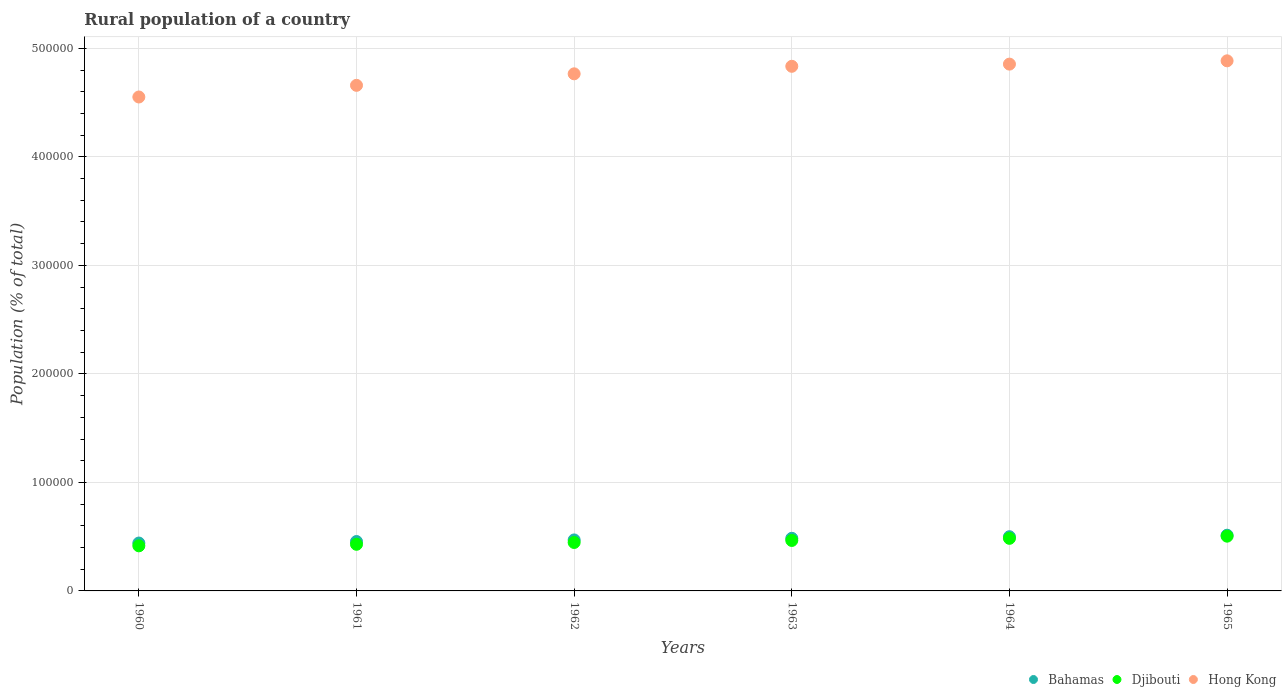Is the number of dotlines equal to the number of legend labels?
Make the answer very short. Yes. What is the rural population in Djibouti in 1962?
Offer a terse response. 4.46e+04. Across all years, what is the maximum rural population in Bahamas?
Your answer should be very brief. 5.13e+04. Across all years, what is the minimum rural population in Djibouti?
Ensure brevity in your answer.  4.15e+04. In which year was the rural population in Hong Kong maximum?
Offer a terse response. 1965. What is the total rural population in Bahamas in the graph?
Your answer should be very brief. 2.86e+05. What is the difference between the rural population in Bahamas in 1962 and that in 1963?
Offer a very short reply. -1491. What is the difference between the rural population in Bahamas in 1960 and the rural population in Djibouti in 1963?
Provide a short and direct response. -2374. What is the average rural population in Bahamas per year?
Offer a very short reply. 4.77e+04. In the year 1963, what is the difference between the rural population in Hong Kong and rural population in Djibouti?
Offer a very short reply. 4.37e+05. What is the ratio of the rural population in Bahamas in 1964 to that in 1965?
Offer a terse response. 0.97. Is the rural population in Hong Kong in 1960 less than that in 1962?
Offer a terse response. Yes. What is the difference between the highest and the second highest rural population in Hong Kong?
Give a very brief answer. 3031. What is the difference between the highest and the lowest rural population in Bahamas?
Make the answer very short. 7212. In how many years, is the rural population in Bahamas greater than the average rural population in Bahamas taken over all years?
Keep it short and to the point. 3. Does the rural population in Hong Kong monotonically increase over the years?
Your answer should be very brief. Yes. Is the rural population in Djibouti strictly less than the rural population in Bahamas over the years?
Keep it short and to the point. Yes. What is the difference between two consecutive major ticks on the Y-axis?
Your answer should be very brief. 1.00e+05. Does the graph contain grids?
Offer a very short reply. Yes. Where does the legend appear in the graph?
Your answer should be very brief. Bottom right. What is the title of the graph?
Keep it short and to the point. Rural population of a country. What is the label or title of the Y-axis?
Ensure brevity in your answer.  Population (% of total). What is the Population (% of total) in Bahamas in 1960?
Give a very brief answer. 4.41e+04. What is the Population (% of total) in Djibouti in 1960?
Your answer should be compact. 4.15e+04. What is the Population (% of total) in Hong Kong in 1960?
Offer a terse response. 4.55e+05. What is the Population (% of total) of Bahamas in 1961?
Keep it short and to the point. 4.55e+04. What is the Population (% of total) in Djibouti in 1961?
Provide a short and direct response. 4.30e+04. What is the Population (% of total) of Hong Kong in 1961?
Your answer should be very brief. 4.66e+05. What is the Population (% of total) of Bahamas in 1962?
Ensure brevity in your answer.  4.70e+04. What is the Population (% of total) of Djibouti in 1962?
Your answer should be compact. 4.46e+04. What is the Population (% of total) in Hong Kong in 1962?
Your response must be concise. 4.77e+05. What is the Population (% of total) of Bahamas in 1963?
Make the answer very short. 4.85e+04. What is the Population (% of total) of Djibouti in 1963?
Keep it short and to the point. 4.65e+04. What is the Population (% of total) in Hong Kong in 1963?
Your answer should be very brief. 4.83e+05. What is the Population (% of total) in Bahamas in 1964?
Offer a terse response. 4.99e+04. What is the Population (% of total) of Djibouti in 1964?
Provide a short and direct response. 4.85e+04. What is the Population (% of total) in Hong Kong in 1964?
Keep it short and to the point. 4.85e+05. What is the Population (% of total) in Bahamas in 1965?
Provide a succinct answer. 5.13e+04. What is the Population (% of total) in Djibouti in 1965?
Ensure brevity in your answer.  5.05e+04. What is the Population (% of total) of Hong Kong in 1965?
Your answer should be very brief. 4.89e+05. Across all years, what is the maximum Population (% of total) in Bahamas?
Ensure brevity in your answer.  5.13e+04. Across all years, what is the maximum Population (% of total) in Djibouti?
Your answer should be compact. 5.05e+04. Across all years, what is the maximum Population (% of total) in Hong Kong?
Offer a terse response. 4.89e+05. Across all years, what is the minimum Population (% of total) in Bahamas?
Your answer should be compact. 4.41e+04. Across all years, what is the minimum Population (% of total) of Djibouti?
Keep it short and to the point. 4.15e+04. Across all years, what is the minimum Population (% of total) of Hong Kong?
Your answer should be very brief. 4.55e+05. What is the total Population (% of total) in Bahamas in the graph?
Your answer should be compact. 2.86e+05. What is the total Population (% of total) of Djibouti in the graph?
Provide a succinct answer. 2.75e+05. What is the total Population (% of total) in Hong Kong in the graph?
Ensure brevity in your answer.  2.86e+06. What is the difference between the Population (% of total) of Bahamas in 1960 and that in 1961?
Ensure brevity in your answer.  -1395. What is the difference between the Population (% of total) in Djibouti in 1960 and that in 1961?
Offer a terse response. -1422. What is the difference between the Population (% of total) of Hong Kong in 1960 and that in 1961?
Ensure brevity in your answer.  -1.07e+04. What is the difference between the Population (% of total) in Bahamas in 1960 and that in 1962?
Your answer should be compact. -2863. What is the difference between the Population (% of total) of Djibouti in 1960 and that in 1962?
Give a very brief answer. -3087. What is the difference between the Population (% of total) in Hong Kong in 1960 and that in 1962?
Your response must be concise. -2.14e+04. What is the difference between the Population (% of total) of Bahamas in 1960 and that in 1963?
Keep it short and to the point. -4354. What is the difference between the Population (% of total) in Djibouti in 1960 and that in 1963?
Offer a very short reply. -4954. What is the difference between the Population (% of total) of Hong Kong in 1960 and that in 1963?
Give a very brief answer. -2.83e+04. What is the difference between the Population (% of total) of Bahamas in 1960 and that in 1964?
Ensure brevity in your answer.  -5821. What is the difference between the Population (% of total) of Djibouti in 1960 and that in 1964?
Your answer should be very brief. -6918. What is the difference between the Population (% of total) in Hong Kong in 1960 and that in 1964?
Your answer should be very brief. -3.03e+04. What is the difference between the Population (% of total) in Bahamas in 1960 and that in 1965?
Ensure brevity in your answer.  -7212. What is the difference between the Population (% of total) of Djibouti in 1960 and that in 1965?
Provide a succinct answer. -8912. What is the difference between the Population (% of total) of Hong Kong in 1960 and that in 1965?
Provide a succinct answer. -3.33e+04. What is the difference between the Population (% of total) of Bahamas in 1961 and that in 1962?
Your answer should be very brief. -1468. What is the difference between the Population (% of total) of Djibouti in 1961 and that in 1962?
Offer a terse response. -1665. What is the difference between the Population (% of total) in Hong Kong in 1961 and that in 1962?
Offer a very short reply. -1.06e+04. What is the difference between the Population (% of total) of Bahamas in 1961 and that in 1963?
Offer a terse response. -2959. What is the difference between the Population (% of total) in Djibouti in 1961 and that in 1963?
Give a very brief answer. -3532. What is the difference between the Population (% of total) in Hong Kong in 1961 and that in 1963?
Keep it short and to the point. -1.75e+04. What is the difference between the Population (% of total) of Bahamas in 1961 and that in 1964?
Ensure brevity in your answer.  -4426. What is the difference between the Population (% of total) of Djibouti in 1961 and that in 1964?
Offer a very short reply. -5496. What is the difference between the Population (% of total) in Hong Kong in 1961 and that in 1964?
Keep it short and to the point. -1.96e+04. What is the difference between the Population (% of total) in Bahamas in 1961 and that in 1965?
Give a very brief answer. -5817. What is the difference between the Population (% of total) of Djibouti in 1961 and that in 1965?
Keep it short and to the point. -7490. What is the difference between the Population (% of total) in Hong Kong in 1961 and that in 1965?
Ensure brevity in your answer.  -2.26e+04. What is the difference between the Population (% of total) of Bahamas in 1962 and that in 1963?
Give a very brief answer. -1491. What is the difference between the Population (% of total) of Djibouti in 1962 and that in 1963?
Provide a succinct answer. -1867. What is the difference between the Population (% of total) of Hong Kong in 1962 and that in 1963?
Offer a very short reply. -6932. What is the difference between the Population (% of total) in Bahamas in 1962 and that in 1964?
Provide a short and direct response. -2958. What is the difference between the Population (% of total) of Djibouti in 1962 and that in 1964?
Make the answer very short. -3831. What is the difference between the Population (% of total) of Hong Kong in 1962 and that in 1964?
Keep it short and to the point. -8948. What is the difference between the Population (% of total) in Bahamas in 1962 and that in 1965?
Provide a succinct answer. -4349. What is the difference between the Population (% of total) in Djibouti in 1962 and that in 1965?
Your response must be concise. -5825. What is the difference between the Population (% of total) of Hong Kong in 1962 and that in 1965?
Provide a succinct answer. -1.20e+04. What is the difference between the Population (% of total) of Bahamas in 1963 and that in 1964?
Ensure brevity in your answer.  -1467. What is the difference between the Population (% of total) in Djibouti in 1963 and that in 1964?
Give a very brief answer. -1964. What is the difference between the Population (% of total) in Hong Kong in 1963 and that in 1964?
Provide a short and direct response. -2016. What is the difference between the Population (% of total) of Bahamas in 1963 and that in 1965?
Make the answer very short. -2858. What is the difference between the Population (% of total) in Djibouti in 1963 and that in 1965?
Provide a short and direct response. -3958. What is the difference between the Population (% of total) of Hong Kong in 1963 and that in 1965?
Offer a terse response. -5047. What is the difference between the Population (% of total) in Bahamas in 1964 and that in 1965?
Give a very brief answer. -1391. What is the difference between the Population (% of total) of Djibouti in 1964 and that in 1965?
Your response must be concise. -1994. What is the difference between the Population (% of total) in Hong Kong in 1964 and that in 1965?
Offer a terse response. -3031. What is the difference between the Population (% of total) in Bahamas in 1960 and the Population (% of total) in Djibouti in 1961?
Provide a short and direct response. 1158. What is the difference between the Population (% of total) in Bahamas in 1960 and the Population (% of total) in Hong Kong in 1961?
Your response must be concise. -4.22e+05. What is the difference between the Population (% of total) in Djibouti in 1960 and the Population (% of total) in Hong Kong in 1961?
Ensure brevity in your answer.  -4.24e+05. What is the difference between the Population (% of total) of Bahamas in 1960 and the Population (% of total) of Djibouti in 1962?
Offer a very short reply. -507. What is the difference between the Population (% of total) in Bahamas in 1960 and the Population (% of total) in Hong Kong in 1962?
Offer a very short reply. -4.32e+05. What is the difference between the Population (% of total) in Djibouti in 1960 and the Population (% of total) in Hong Kong in 1962?
Ensure brevity in your answer.  -4.35e+05. What is the difference between the Population (% of total) in Bahamas in 1960 and the Population (% of total) in Djibouti in 1963?
Your answer should be very brief. -2374. What is the difference between the Population (% of total) of Bahamas in 1960 and the Population (% of total) of Hong Kong in 1963?
Provide a succinct answer. -4.39e+05. What is the difference between the Population (% of total) in Djibouti in 1960 and the Population (% of total) in Hong Kong in 1963?
Ensure brevity in your answer.  -4.42e+05. What is the difference between the Population (% of total) in Bahamas in 1960 and the Population (% of total) in Djibouti in 1964?
Give a very brief answer. -4338. What is the difference between the Population (% of total) in Bahamas in 1960 and the Population (% of total) in Hong Kong in 1964?
Offer a very short reply. -4.41e+05. What is the difference between the Population (% of total) of Djibouti in 1960 and the Population (% of total) of Hong Kong in 1964?
Offer a terse response. -4.44e+05. What is the difference between the Population (% of total) of Bahamas in 1960 and the Population (% of total) of Djibouti in 1965?
Offer a very short reply. -6332. What is the difference between the Population (% of total) in Bahamas in 1960 and the Population (% of total) in Hong Kong in 1965?
Ensure brevity in your answer.  -4.44e+05. What is the difference between the Population (% of total) in Djibouti in 1960 and the Population (% of total) in Hong Kong in 1965?
Give a very brief answer. -4.47e+05. What is the difference between the Population (% of total) in Bahamas in 1961 and the Population (% of total) in Djibouti in 1962?
Offer a very short reply. 888. What is the difference between the Population (% of total) of Bahamas in 1961 and the Population (% of total) of Hong Kong in 1962?
Provide a succinct answer. -4.31e+05. What is the difference between the Population (% of total) in Djibouti in 1961 and the Population (% of total) in Hong Kong in 1962?
Ensure brevity in your answer.  -4.34e+05. What is the difference between the Population (% of total) in Bahamas in 1961 and the Population (% of total) in Djibouti in 1963?
Offer a terse response. -979. What is the difference between the Population (% of total) of Bahamas in 1961 and the Population (% of total) of Hong Kong in 1963?
Your response must be concise. -4.38e+05. What is the difference between the Population (% of total) in Djibouti in 1961 and the Population (% of total) in Hong Kong in 1963?
Your answer should be compact. -4.41e+05. What is the difference between the Population (% of total) of Bahamas in 1961 and the Population (% of total) of Djibouti in 1964?
Keep it short and to the point. -2943. What is the difference between the Population (% of total) in Bahamas in 1961 and the Population (% of total) in Hong Kong in 1964?
Your answer should be very brief. -4.40e+05. What is the difference between the Population (% of total) of Djibouti in 1961 and the Population (% of total) of Hong Kong in 1964?
Provide a short and direct response. -4.43e+05. What is the difference between the Population (% of total) of Bahamas in 1961 and the Population (% of total) of Djibouti in 1965?
Make the answer very short. -4937. What is the difference between the Population (% of total) in Bahamas in 1961 and the Population (% of total) in Hong Kong in 1965?
Your answer should be compact. -4.43e+05. What is the difference between the Population (% of total) of Djibouti in 1961 and the Population (% of total) of Hong Kong in 1965?
Offer a very short reply. -4.46e+05. What is the difference between the Population (% of total) of Bahamas in 1962 and the Population (% of total) of Djibouti in 1963?
Your response must be concise. 489. What is the difference between the Population (% of total) of Bahamas in 1962 and the Population (% of total) of Hong Kong in 1963?
Keep it short and to the point. -4.36e+05. What is the difference between the Population (% of total) of Djibouti in 1962 and the Population (% of total) of Hong Kong in 1963?
Give a very brief answer. -4.39e+05. What is the difference between the Population (% of total) of Bahamas in 1962 and the Population (% of total) of Djibouti in 1964?
Your response must be concise. -1475. What is the difference between the Population (% of total) in Bahamas in 1962 and the Population (% of total) in Hong Kong in 1964?
Keep it short and to the point. -4.39e+05. What is the difference between the Population (% of total) in Djibouti in 1962 and the Population (% of total) in Hong Kong in 1964?
Provide a succinct answer. -4.41e+05. What is the difference between the Population (% of total) in Bahamas in 1962 and the Population (% of total) in Djibouti in 1965?
Keep it short and to the point. -3469. What is the difference between the Population (% of total) in Bahamas in 1962 and the Population (% of total) in Hong Kong in 1965?
Your answer should be compact. -4.42e+05. What is the difference between the Population (% of total) in Djibouti in 1962 and the Population (% of total) in Hong Kong in 1965?
Your answer should be compact. -4.44e+05. What is the difference between the Population (% of total) of Bahamas in 1963 and the Population (% of total) of Hong Kong in 1964?
Ensure brevity in your answer.  -4.37e+05. What is the difference between the Population (% of total) of Djibouti in 1963 and the Population (% of total) of Hong Kong in 1964?
Your response must be concise. -4.39e+05. What is the difference between the Population (% of total) in Bahamas in 1963 and the Population (% of total) in Djibouti in 1965?
Provide a succinct answer. -1978. What is the difference between the Population (% of total) in Bahamas in 1963 and the Population (% of total) in Hong Kong in 1965?
Make the answer very short. -4.40e+05. What is the difference between the Population (% of total) of Djibouti in 1963 and the Population (% of total) of Hong Kong in 1965?
Make the answer very short. -4.42e+05. What is the difference between the Population (% of total) in Bahamas in 1964 and the Population (% of total) in Djibouti in 1965?
Keep it short and to the point. -511. What is the difference between the Population (% of total) in Bahamas in 1964 and the Population (% of total) in Hong Kong in 1965?
Ensure brevity in your answer.  -4.39e+05. What is the difference between the Population (% of total) of Djibouti in 1964 and the Population (% of total) of Hong Kong in 1965?
Ensure brevity in your answer.  -4.40e+05. What is the average Population (% of total) in Bahamas per year?
Give a very brief answer. 4.77e+04. What is the average Population (% of total) of Djibouti per year?
Provide a short and direct response. 4.58e+04. What is the average Population (% of total) of Hong Kong per year?
Provide a succinct answer. 4.76e+05. In the year 1960, what is the difference between the Population (% of total) of Bahamas and Population (% of total) of Djibouti?
Your response must be concise. 2580. In the year 1960, what is the difference between the Population (% of total) in Bahamas and Population (% of total) in Hong Kong?
Offer a terse response. -4.11e+05. In the year 1960, what is the difference between the Population (% of total) of Djibouti and Population (% of total) of Hong Kong?
Your answer should be compact. -4.14e+05. In the year 1961, what is the difference between the Population (% of total) in Bahamas and Population (% of total) in Djibouti?
Your answer should be very brief. 2553. In the year 1961, what is the difference between the Population (% of total) in Bahamas and Population (% of total) in Hong Kong?
Make the answer very short. -4.20e+05. In the year 1961, what is the difference between the Population (% of total) of Djibouti and Population (% of total) of Hong Kong?
Your answer should be very brief. -4.23e+05. In the year 1962, what is the difference between the Population (% of total) in Bahamas and Population (% of total) in Djibouti?
Keep it short and to the point. 2356. In the year 1962, what is the difference between the Population (% of total) in Bahamas and Population (% of total) in Hong Kong?
Make the answer very short. -4.30e+05. In the year 1962, what is the difference between the Population (% of total) in Djibouti and Population (% of total) in Hong Kong?
Offer a very short reply. -4.32e+05. In the year 1963, what is the difference between the Population (% of total) in Bahamas and Population (% of total) in Djibouti?
Your answer should be very brief. 1980. In the year 1963, what is the difference between the Population (% of total) in Bahamas and Population (% of total) in Hong Kong?
Ensure brevity in your answer.  -4.35e+05. In the year 1963, what is the difference between the Population (% of total) of Djibouti and Population (% of total) of Hong Kong?
Your answer should be compact. -4.37e+05. In the year 1964, what is the difference between the Population (% of total) of Bahamas and Population (% of total) of Djibouti?
Your answer should be very brief. 1483. In the year 1964, what is the difference between the Population (% of total) in Bahamas and Population (% of total) in Hong Kong?
Ensure brevity in your answer.  -4.36e+05. In the year 1964, what is the difference between the Population (% of total) of Djibouti and Population (% of total) of Hong Kong?
Keep it short and to the point. -4.37e+05. In the year 1965, what is the difference between the Population (% of total) in Bahamas and Population (% of total) in Djibouti?
Offer a very short reply. 880. In the year 1965, what is the difference between the Population (% of total) of Bahamas and Population (% of total) of Hong Kong?
Your response must be concise. -4.37e+05. In the year 1965, what is the difference between the Population (% of total) of Djibouti and Population (% of total) of Hong Kong?
Keep it short and to the point. -4.38e+05. What is the ratio of the Population (% of total) of Bahamas in 1960 to that in 1961?
Offer a terse response. 0.97. What is the ratio of the Population (% of total) in Djibouti in 1960 to that in 1961?
Ensure brevity in your answer.  0.97. What is the ratio of the Population (% of total) in Hong Kong in 1960 to that in 1961?
Give a very brief answer. 0.98. What is the ratio of the Population (% of total) in Bahamas in 1960 to that in 1962?
Your answer should be compact. 0.94. What is the ratio of the Population (% of total) in Djibouti in 1960 to that in 1962?
Offer a very short reply. 0.93. What is the ratio of the Population (% of total) in Hong Kong in 1960 to that in 1962?
Give a very brief answer. 0.96. What is the ratio of the Population (% of total) in Bahamas in 1960 to that in 1963?
Your answer should be very brief. 0.91. What is the ratio of the Population (% of total) of Djibouti in 1960 to that in 1963?
Keep it short and to the point. 0.89. What is the ratio of the Population (% of total) in Hong Kong in 1960 to that in 1963?
Provide a succinct answer. 0.94. What is the ratio of the Population (% of total) in Bahamas in 1960 to that in 1964?
Offer a terse response. 0.88. What is the ratio of the Population (% of total) of Djibouti in 1960 to that in 1964?
Provide a short and direct response. 0.86. What is the ratio of the Population (% of total) in Hong Kong in 1960 to that in 1964?
Your answer should be compact. 0.94. What is the ratio of the Population (% of total) of Bahamas in 1960 to that in 1965?
Your answer should be very brief. 0.86. What is the ratio of the Population (% of total) of Djibouti in 1960 to that in 1965?
Offer a very short reply. 0.82. What is the ratio of the Population (% of total) in Hong Kong in 1960 to that in 1965?
Ensure brevity in your answer.  0.93. What is the ratio of the Population (% of total) of Bahamas in 1961 to that in 1962?
Make the answer very short. 0.97. What is the ratio of the Population (% of total) of Djibouti in 1961 to that in 1962?
Offer a very short reply. 0.96. What is the ratio of the Population (% of total) in Hong Kong in 1961 to that in 1962?
Provide a succinct answer. 0.98. What is the ratio of the Population (% of total) in Bahamas in 1961 to that in 1963?
Ensure brevity in your answer.  0.94. What is the ratio of the Population (% of total) of Djibouti in 1961 to that in 1963?
Ensure brevity in your answer.  0.92. What is the ratio of the Population (% of total) of Hong Kong in 1961 to that in 1963?
Make the answer very short. 0.96. What is the ratio of the Population (% of total) in Bahamas in 1961 to that in 1964?
Keep it short and to the point. 0.91. What is the ratio of the Population (% of total) of Djibouti in 1961 to that in 1964?
Your response must be concise. 0.89. What is the ratio of the Population (% of total) of Hong Kong in 1961 to that in 1964?
Keep it short and to the point. 0.96. What is the ratio of the Population (% of total) of Bahamas in 1961 to that in 1965?
Ensure brevity in your answer.  0.89. What is the ratio of the Population (% of total) in Djibouti in 1961 to that in 1965?
Keep it short and to the point. 0.85. What is the ratio of the Population (% of total) in Hong Kong in 1961 to that in 1965?
Ensure brevity in your answer.  0.95. What is the ratio of the Population (% of total) of Bahamas in 1962 to that in 1963?
Your answer should be very brief. 0.97. What is the ratio of the Population (% of total) of Djibouti in 1962 to that in 1963?
Your response must be concise. 0.96. What is the ratio of the Population (% of total) in Hong Kong in 1962 to that in 1963?
Provide a short and direct response. 0.99. What is the ratio of the Population (% of total) in Bahamas in 1962 to that in 1964?
Provide a short and direct response. 0.94. What is the ratio of the Population (% of total) of Djibouti in 1962 to that in 1964?
Your response must be concise. 0.92. What is the ratio of the Population (% of total) in Hong Kong in 1962 to that in 1964?
Offer a very short reply. 0.98. What is the ratio of the Population (% of total) in Bahamas in 1962 to that in 1965?
Your response must be concise. 0.92. What is the ratio of the Population (% of total) of Djibouti in 1962 to that in 1965?
Offer a very short reply. 0.88. What is the ratio of the Population (% of total) in Hong Kong in 1962 to that in 1965?
Your answer should be very brief. 0.98. What is the ratio of the Population (% of total) in Bahamas in 1963 to that in 1964?
Your answer should be compact. 0.97. What is the ratio of the Population (% of total) in Djibouti in 1963 to that in 1964?
Make the answer very short. 0.96. What is the ratio of the Population (% of total) of Bahamas in 1963 to that in 1965?
Ensure brevity in your answer.  0.94. What is the ratio of the Population (% of total) of Djibouti in 1963 to that in 1965?
Offer a very short reply. 0.92. What is the ratio of the Population (% of total) of Hong Kong in 1963 to that in 1965?
Give a very brief answer. 0.99. What is the ratio of the Population (% of total) of Bahamas in 1964 to that in 1965?
Ensure brevity in your answer.  0.97. What is the ratio of the Population (% of total) in Djibouti in 1964 to that in 1965?
Provide a short and direct response. 0.96. What is the difference between the highest and the second highest Population (% of total) in Bahamas?
Your answer should be compact. 1391. What is the difference between the highest and the second highest Population (% of total) in Djibouti?
Provide a short and direct response. 1994. What is the difference between the highest and the second highest Population (% of total) of Hong Kong?
Offer a terse response. 3031. What is the difference between the highest and the lowest Population (% of total) in Bahamas?
Offer a very short reply. 7212. What is the difference between the highest and the lowest Population (% of total) in Djibouti?
Offer a very short reply. 8912. What is the difference between the highest and the lowest Population (% of total) of Hong Kong?
Make the answer very short. 3.33e+04. 